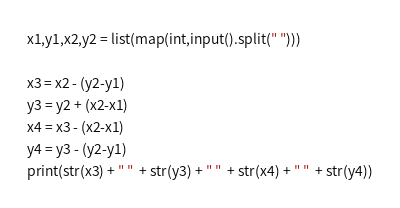<code> <loc_0><loc_0><loc_500><loc_500><_Python_>x1,y1,x2,y2 = list(map(int,input().split(" ")))

x3 = x2 - (y2-y1)
y3 = y2 + (x2-x1)
x4 = x3 - (x2-x1)
y4 = y3 - (y2-y1)
print(str(x3) + " "  + str(y3) + " "  + str(x4) + " "  + str(y4))
</code> 